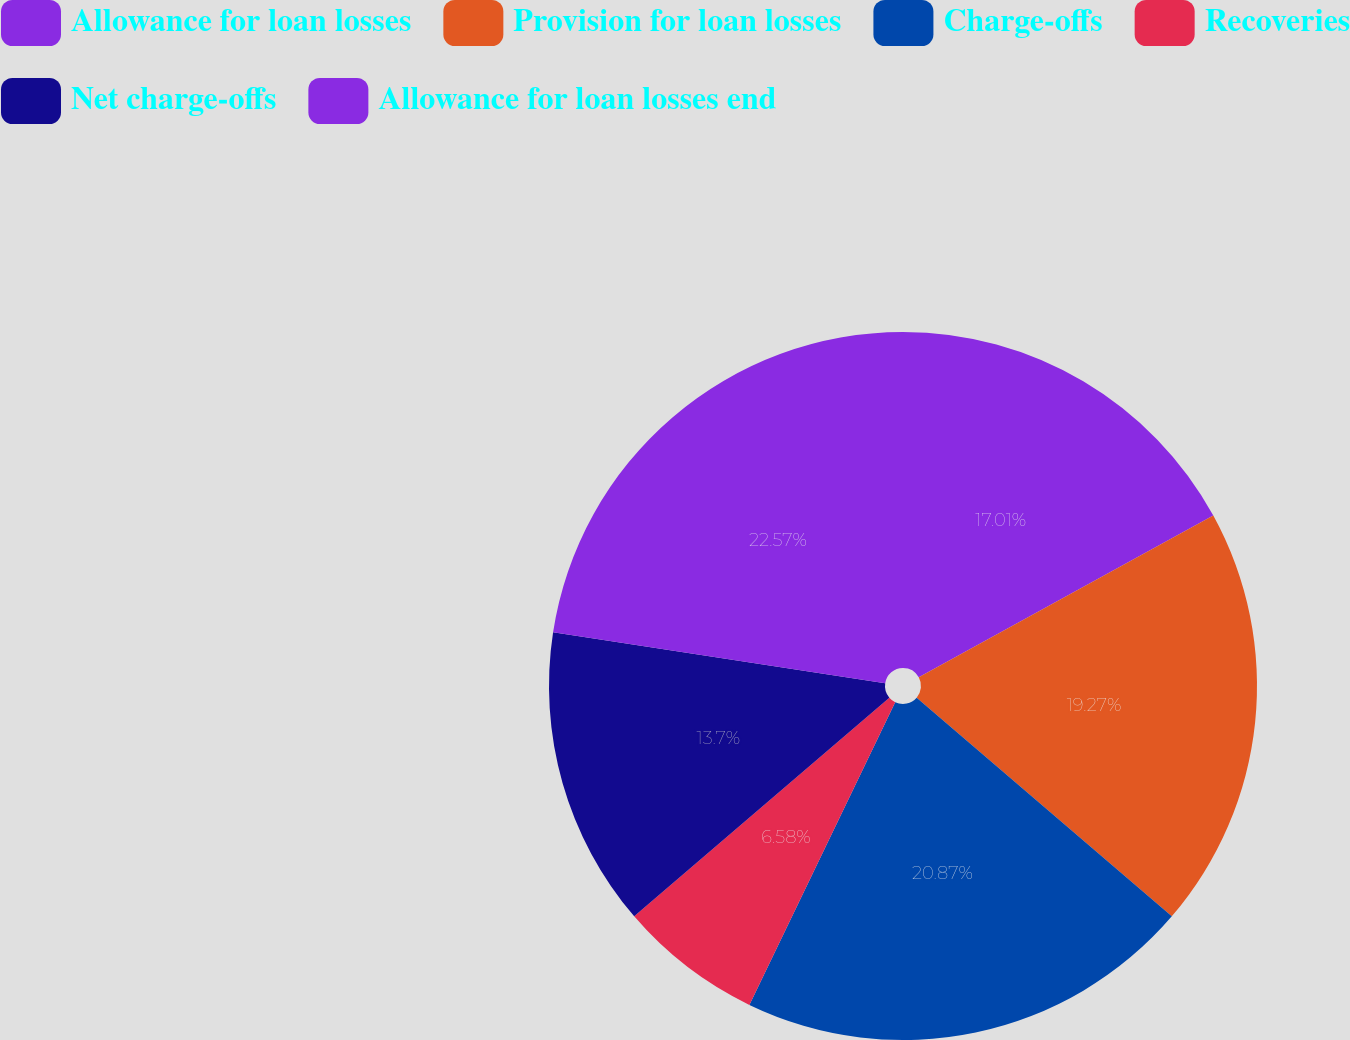<chart> <loc_0><loc_0><loc_500><loc_500><pie_chart><fcel>Allowance for loan losses<fcel>Provision for loan losses<fcel>Charge-offs<fcel>Recoveries<fcel>Net charge-offs<fcel>Allowance for loan losses end<nl><fcel>17.01%<fcel>19.27%<fcel>20.87%<fcel>6.58%<fcel>13.7%<fcel>22.58%<nl></chart> 